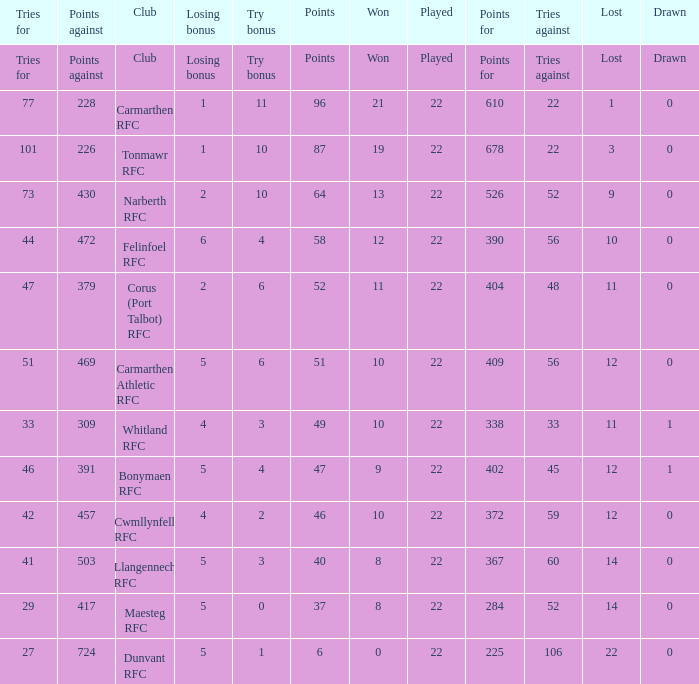Name the try bonus of points against at 430 10.0. 